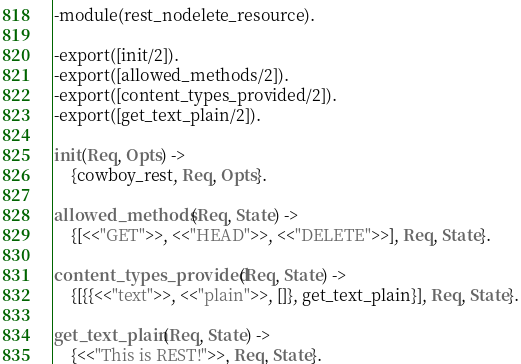Convert code to text. <code><loc_0><loc_0><loc_500><loc_500><_Erlang_>-module(rest_nodelete_resource).

-export([init/2]).
-export([allowed_methods/2]).
-export([content_types_provided/2]).
-export([get_text_plain/2]).

init(Req, Opts) ->
	{cowboy_rest, Req, Opts}.

allowed_methods(Req, State) ->
	{[<<"GET">>, <<"HEAD">>, <<"DELETE">>], Req, State}.

content_types_provided(Req, State) ->
	{[{{<<"text">>, <<"plain">>, []}, get_text_plain}], Req, State}.

get_text_plain(Req, State) ->
	{<<"This is REST!">>, Req, State}.
</code> 